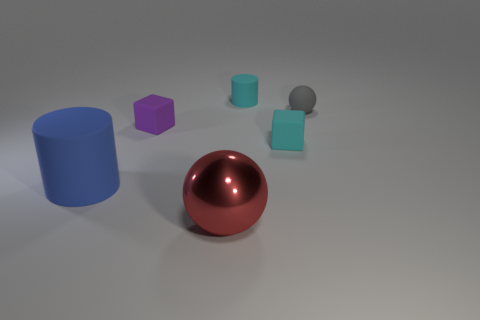Add 1 matte objects. How many objects exist? 7 Subtract all cylinders. How many objects are left? 4 Subtract 0 green balls. How many objects are left? 6 Subtract all tiny cylinders. Subtract all small cyan rubber cylinders. How many objects are left? 4 Add 3 cylinders. How many cylinders are left? 5 Add 5 small matte spheres. How many small matte spheres exist? 6 